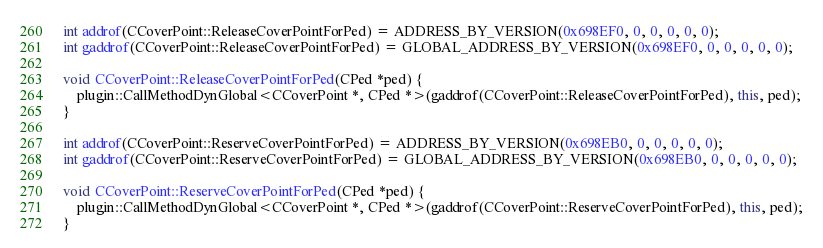<code> <loc_0><loc_0><loc_500><loc_500><_C++_>
int addrof(CCoverPoint::ReleaseCoverPointForPed) = ADDRESS_BY_VERSION(0x698EF0, 0, 0, 0, 0, 0);
int gaddrof(CCoverPoint::ReleaseCoverPointForPed) = GLOBAL_ADDRESS_BY_VERSION(0x698EF0, 0, 0, 0, 0, 0);

void CCoverPoint::ReleaseCoverPointForPed(CPed *ped) {
    plugin::CallMethodDynGlobal<CCoverPoint *, CPed *>(gaddrof(CCoverPoint::ReleaseCoverPointForPed), this, ped);
}

int addrof(CCoverPoint::ReserveCoverPointForPed) = ADDRESS_BY_VERSION(0x698EB0, 0, 0, 0, 0, 0);
int gaddrof(CCoverPoint::ReserveCoverPointForPed) = GLOBAL_ADDRESS_BY_VERSION(0x698EB0, 0, 0, 0, 0, 0);

void CCoverPoint::ReserveCoverPointForPed(CPed *ped) {
    plugin::CallMethodDynGlobal<CCoverPoint *, CPed *>(gaddrof(CCoverPoint::ReserveCoverPointForPed), this, ped);
}
</code> 